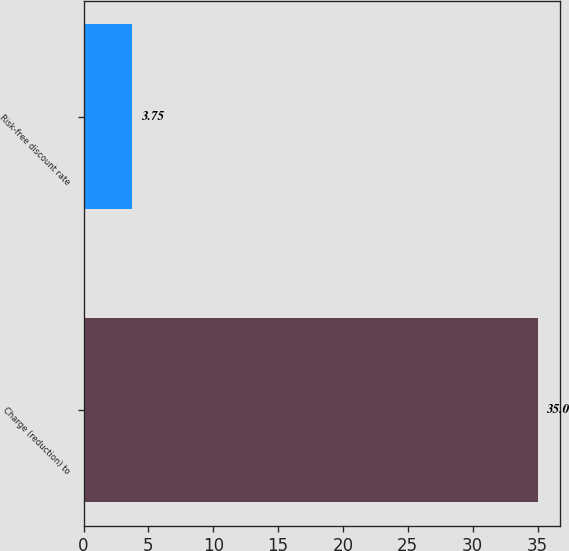Convert chart. <chart><loc_0><loc_0><loc_500><loc_500><bar_chart><fcel>Charge (reduction) to<fcel>Risk-free discount rate<nl><fcel>35<fcel>3.75<nl></chart> 